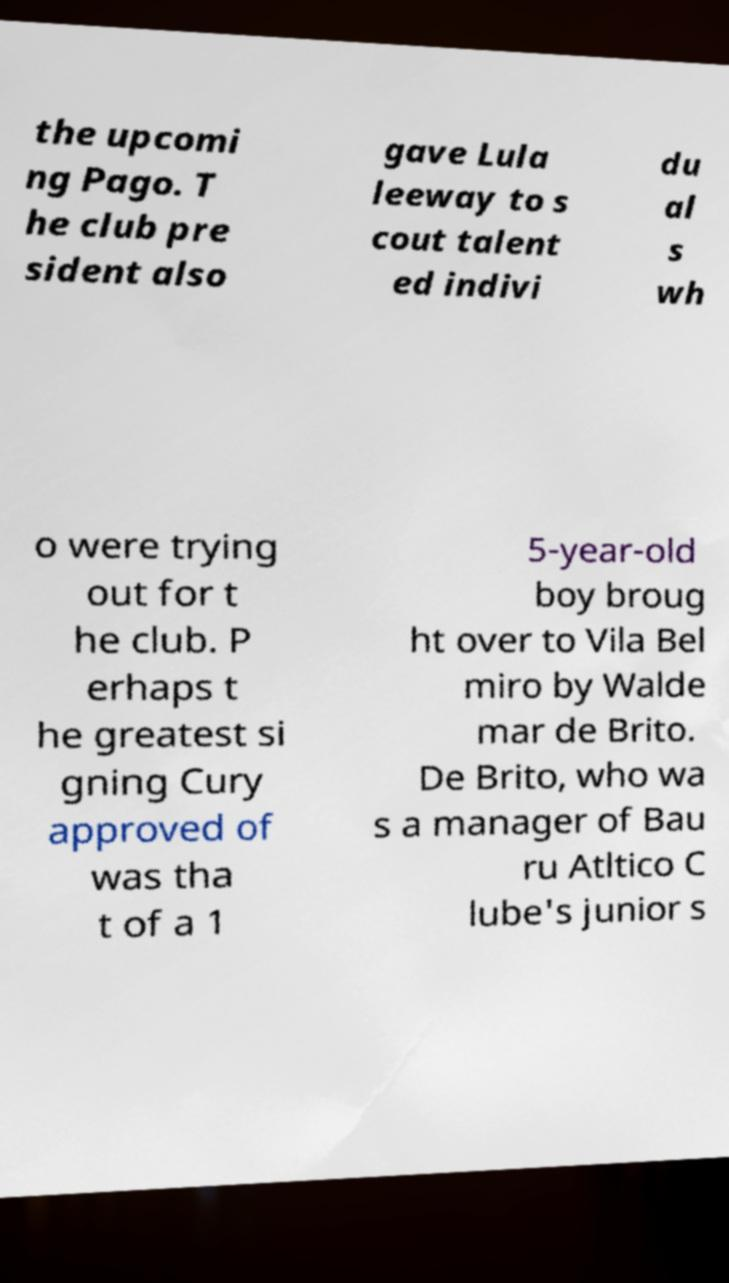Could you extract and type out the text from this image? the upcomi ng Pago. T he club pre sident also gave Lula leeway to s cout talent ed indivi du al s wh o were trying out for t he club. P erhaps t he greatest si gning Cury approved of was tha t of a 1 5-year-old boy broug ht over to Vila Bel miro by Walde mar de Brito. De Brito, who wa s a manager of Bau ru Atltico C lube's junior s 